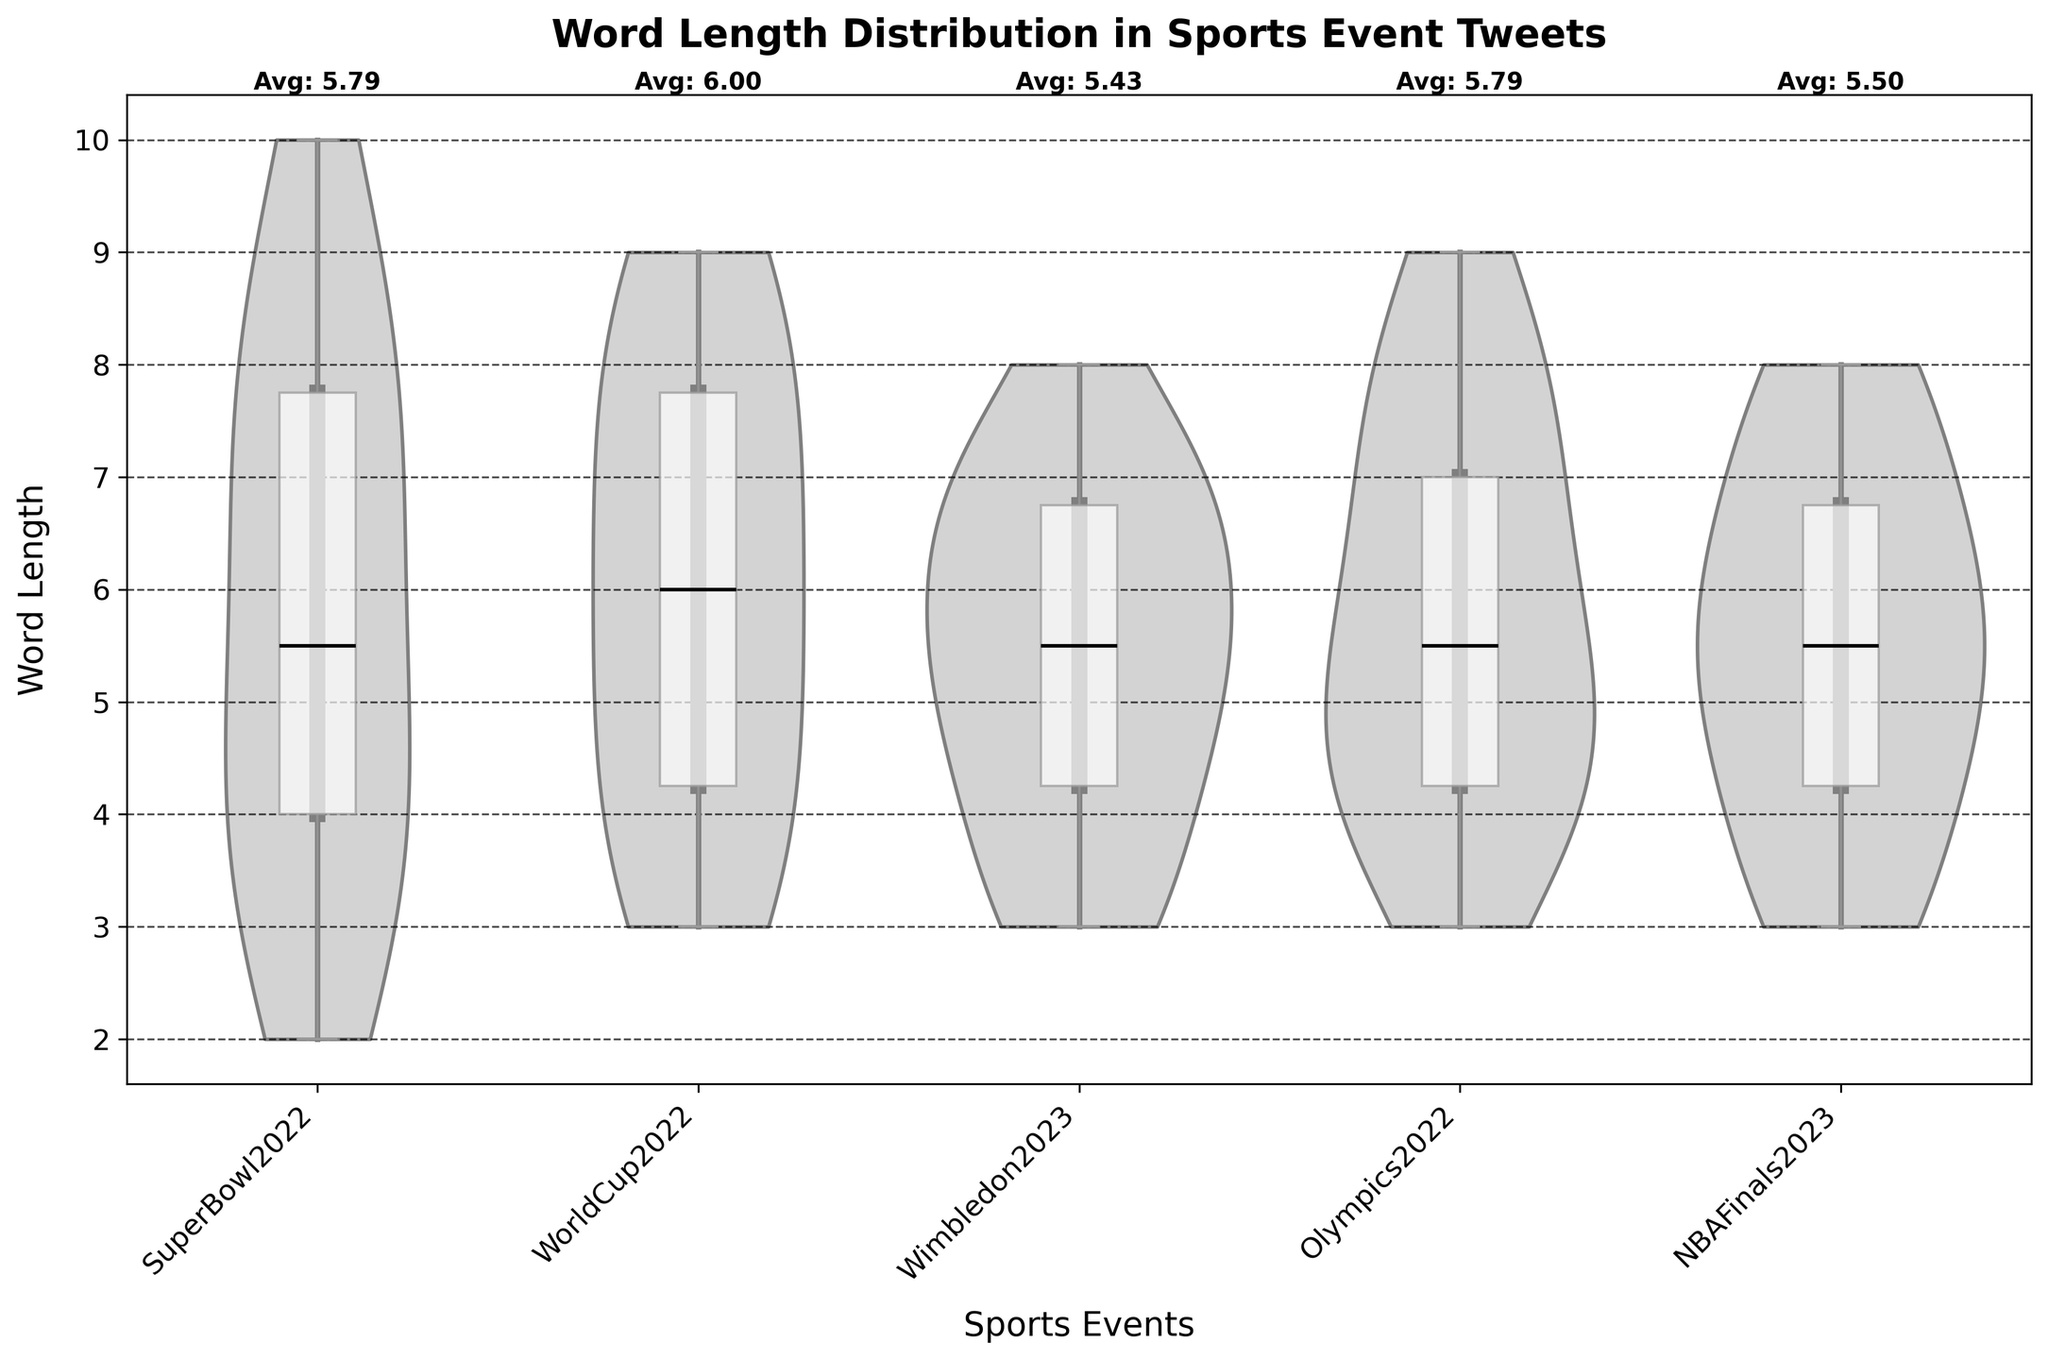What's the title of the figure? The title is displayed prominently at the top of the figure.
Answer: Word Length Distribution in Sports Event Tweets What do the colors in the figure represent? The figure uses grayscale. The violins are in light gray, box plots in white, and medians are marked in black.
Answer: Grayscale representation What is the average word length for tweets from the Super Bowl 2022? Locate the "SuperBowl2022" section. The average word length is labeled next to this section.
Answer: Avg: 5.64 Which event has the highest median word length in tweets? Look at the medians marked in black in the box plots for each event. Identify the event with the highest median point.
Answer: Olympics2022 Compare the word length distribution between World Cup 2022 and Wimbledon 2023. Check both the violin shapes and box plots for "WorldCup2022" and "Wimbledon2023." Note the range, spread, and median positions.
Answer: WorldCup2022 has a broader distribution and higher median What is the word length range for tweets from the NBA Finals 2023? Look at the top and bottom ends of the violin and corresponding box plot for "NBAFinals2023" to determine the minimum and maximum points.
Answer: 3 to 8 How does the maximum word length in the Super Bowl 2022 tweets compare to the Olympics 2022 tweets? Compare the topmost point of the violins or box plots for both "SuperBowl2022" and "Olympics2022."
Answer: Both have a maximum of 10 Which event has the smallest range in word length for tweets? Examine the box plots to identify the event with the closest minimum and maximum whiskers.
Answer: Wimbledon2023 Is there any event with the median word length of exactly 6? Look at the black lines in the box plots to check if any align with 6.
Answer: None Which two events have similar average word lengths in tweets? Look at the average values labeled next to each event and identify two that are close in value.
Answer: SuperBowl2022 and NBAFinals2023 